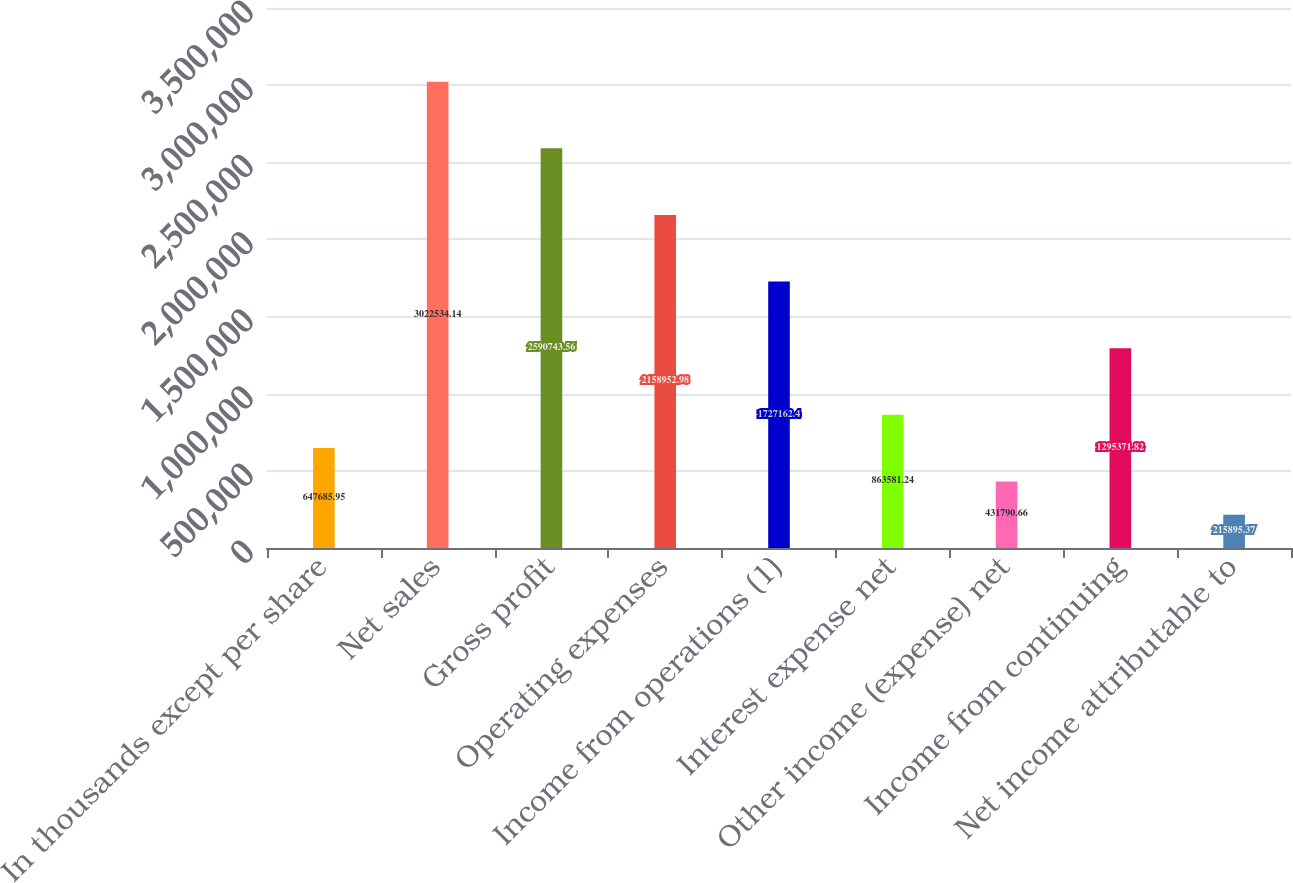<chart> <loc_0><loc_0><loc_500><loc_500><bar_chart><fcel>In thousands except per share<fcel>Net sales<fcel>Gross profit<fcel>Operating expenses<fcel>Income from operations (1)<fcel>Interest expense net<fcel>Other income (expense) net<fcel>Income from continuing<fcel>Net income attributable to<nl><fcel>647686<fcel>3.02253e+06<fcel>2.59074e+06<fcel>2.15895e+06<fcel>1.72716e+06<fcel>863581<fcel>431791<fcel>1.29537e+06<fcel>215895<nl></chart> 